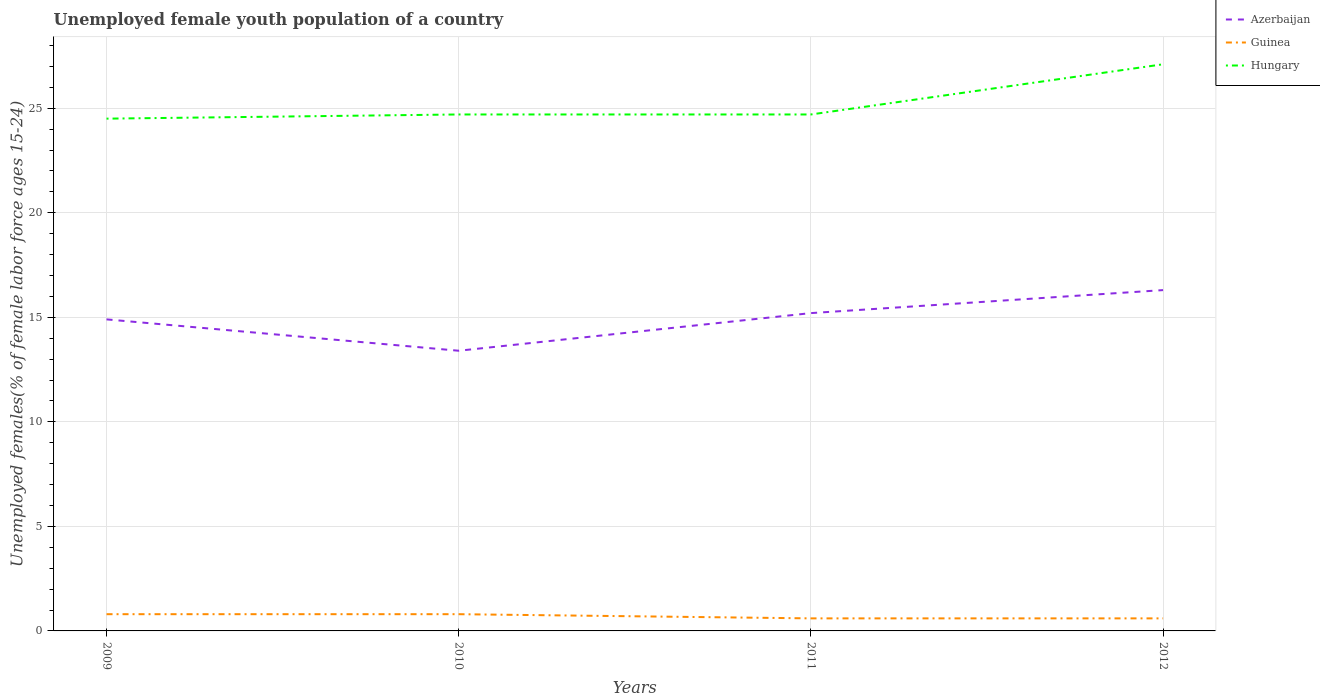Does the line corresponding to Hungary intersect with the line corresponding to Guinea?
Offer a very short reply. No. Is the number of lines equal to the number of legend labels?
Your response must be concise. Yes. Across all years, what is the maximum percentage of unemployed female youth population in Hungary?
Make the answer very short. 24.5. What is the difference between the highest and the second highest percentage of unemployed female youth population in Azerbaijan?
Make the answer very short. 2.9. How many lines are there?
Make the answer very short. 3. How many years are there in the graph?
Your answer should be compact. 4. Are the values on the major ticks of Y-axis written in scientific E-notation?
Your answer should be compact. No. Does the graph contain any zero values?
Ensure brevity in your answer.  No. Where does the legend appear in the graph?
Your answer should be very brief. Top right. How many legend labels are there?
Your answer should be compact. 3. What is the title of the graph?
Your answer should be compact. Unemployed female youth population of a country. What is the label or title of the X-axis?
Ensure brevity in your answer.  Years. What is the label or title of the Y-axis?
Your answer should be compact. Unemployed females(% of female labor force ages 15-24). What is the Unemployed females(% of female labor force ages 15-24) of Azerbaijan in 2009?
Your answer should be very brief. 14.9. What is the Unemployed females(% of female labor force ages 15-24) in Guinea in 2009?
Make the answer very short. 0.8. What is the Unemployed females(% of female labor force ages 15-24) in Hungary in 2009?
Keep it short and to the point. 24.5. What is the Unemployed females(% of female labor force ages 15-24) of Azerbaijan in 2010?
Your response must be concise. 13.4. What is the Unemployed females(% of female labor force ages 15-24) of Guinea in 2010?
Your answer should be compact. 0.8. What is the Unemployed females(% of female labor force ages 15-24) of Hungary in 2010?
Provide a succinct answer. 24.7. What is the Unemployed females(% of female labor force ages 15-24) in Azerbaijan in 2011?
Keep it short and to the point. 15.2. What is the Unemployed females(% of female labor force ages 15-24) of Guinea in 2011?
Ensure brevity in your answer.  0.6. What is the Unemployed females(% of female labor force ages 15-24) in Hungary in 2011?
Offer a very short reply. 24.7. What is the Unemployed females(% of female labor force ages 15-24) of Azerbaijan in 2012?
Give a very brief answer. 16.3. What is the Unemployed females(% of female labor force ages 15-24) of Guinea in 2012?
Offer a very short reply. 0.6. What is the Unemployed females(% of female labor force ages 15-24) in Hungary in 2012?
Make the answer very short. 27.1. Across all years, what is the maximum Unemployed females(% of female labor force ages 15-24) of Azerbaijan?
Offer a terse response. 16.3. Across all years, what is the maximum Unemployed females(% of female labor force ages 15-24) in Guinea?
Make the answer very short. 0.8. Across all years, what is the maximum Unemployed females(% of female labor force ages 15-24) of Hungary?
Provide a short and direct response. 27.1. Across all years, what is the minimum Unemployed females(% of female labor force ages 15-24) in Azerbaijan?
Give a very brief answer. 13.4. Across all years, what is the minimum Unemployed females(% of female labor force ages 15-24) of Guinea?
Make the answer very short. 0.6. Across all years, what is the minimum Unemployed females(% of female labor force ages 15-24) in Hungary?
Provide a succinct answer. 24.5. What is the total Unemployed females(% of female labor force ages 15-24) of Azerbaijan in the graph?
Provide a short and direct response. 59.8. What is the total Unemployed females(% of female labor force ages 15-24) of Hungary in the graph?
Offer a very short reply. 101. What is the difference between the Unemployed females(% of female labor force ages 15-24) in Azerbaijan in 2009 and that in 2010?
Provide a succinct answer. 1.5. What is the difference between the Unemployed females(% of female labor force ages 15-24) of Azerbaijan in 2009 and that in 2011?
Your answer should be very brief. -0.3. What is the difference between the Unemployed females(% of female labor force ages 15-24) of Hungary in 2009 and that in 2011?
Offer a very short reply. -0.2. What is the difference between the Unemployed females(% of female labor force ages 15-24) in Azerbaijan in 2010 and that in 2011?
Give a very brief answer. -1.8. What is the difference between the Unemployed females(% of female labor force ages 15-24) in Guinea in 2010 and that in 2011?
Keep it short and to the point. 0.2. What is the difference between the Unemployed females(% of female labor force ages 15-24) of Hungary in 2010 and that in 2011?
Offer a terse response. 0. What is the difference between the Unemployed females(% of female labor force ages 15-24) in Azerbaijan in 2010 and that in 2012?
Make the answer very short. -2.9. What is the difference between the Unemployed females(% of female labor force ages 15-24) of Guinea in 2010 and that in 2012?
Offer a very short reply. 0.2. What is the difference between the Unemployed females(% of female labor force ages 15-24) in Azerbaijan in 2011 and that in 2012?
Your answer should be compact. -1.1. What is the difference between the Unemployed females(% of female labor force ages 15-24) of Guinea in 2011 and that in 2012?
Ensure brevity in your answer.  0. What is the difference between the Unemployed females(% of female labor force ages 15-24) of Azerbaijan in 2009 and the Unemployed females(% of female labor force ages 15-24) of Guinea in 2010?
Provide a succinct answer. 14.1. What is the difference between the Unemployed females(% of female labor force ages 15-24) in Azerbaijan in 2009 and the Unemployed females(% of female labor force ages 15-24) in Hungary in 2010?
Provide a short and direct response. -9.8. What is the difference between the Unemployed females(% of female labor force ages 15-24) in Guinea in 2009 and the Unemployed females(% of female labor force ages 15-24) in Hungary in 2010?
Make the answer very short. -23.9. What is the difference between the Unemployed females(% of female labor force ages 15-24) of Azerbaijan in 2009 and the Unemployed females(% of female labor force ages 15-24) of Hungary in 2011?
Your answer should be compact. -9.8. What is the difference between the Unemployed females(% of female labor force ages 15-24) of Guinea in 2009 and the Unemployed females(% of female labor force ages 15-24) of Hungary in 2011?
Offer a terse response. -23.9. What is the difference between the Unemployed females(% of female labor force ages 15-24) of Azerbaijan in 2009 and the Unemployed females(% of female labor force ages 15-24) of Guinea in 2012?
Your answer should be compact. 14.3. What is the difference between the Unemployed females(% of female labor force ages 15-24) of Azerbaijan in 2009 and the Unemployed females(% of female labor force ages 15-24) of Hungary in 2012?
Your answer should be compact. -12.2. What is the difference between the Unemployed females(% of female labor force ages 15-24) in Guinea in 2009 and the Unemployed females(% of female labor force ages 15-24) in Hungary in 2012?
Keep it short and to the point. -26.3. What is the difference between the Unemployed females(% of female labor force ages 15-24) of Azerbaijan in 2010 and the Unemployed females(% of female labor force ages 15-24) of Guinea in 2011?
Your response must be concise. 12.8. What is the difference between the Unemployed females(% of female labor force ages 15-24) in Azerbaijan in 2010 and the Unemployed females(% of female labor force ages 15-24) in Hungary in 2011?
Provide a short and direct response. -11.3. What is the difference between the Unemployed females(% of female labor force ages 15-24) in Guinea in 2010 and the Unemployed females(% of female labor force ages 15-24) in Hungary in 2011?
Your answer should be compact. -23.9. What is the difference between the Unemployed females(% of female labor force ages 15-24) of Azerbaijan in 2010 and the Unemployed females(% of female labor force ages 15-24) of Guinea in 2012?
Your answer should be compact. 12.8. What is the difference between the Unemployed females(% of female labor force ages 15-24) of Azerbaijan in 2010 and the Unemployed females(% of female labor force ages 15-24) of Hungary in 2012?
Offer a very short reply. -13.7. What is the difference between the Unemployed females(% of female labor force ages 15-24) in Guinea in 2010 and the Unemployed females(% of female labor force ages 15-24) in Hungary in 2012?
Keep it short and to the point. -26.3. What is the difference between the Unemployed females(% of female labor force ages 15-24) of Guinea in 2011 and the Unemployed females(% of female labor force ages 15-24) of Hungary in 2012?
Make the answer very short. -26.5. What is the average Unemployed females(% of female labor force ages 15-24) in Azerbaijan per year?
Provide a short and direct response. 14.95. What is the average Unemployed females(% of female labor force ages 15-24) of Hungary per year?
Ensure brevity in your answer.  25.25. In the year 2009, what is the difference between the Unemployed females(% of female labor force ages 15-24) of Guinea and Unemployed females(% of female labor force ages 15-24) of Hungary?
Provide a succinct answer. -23.7. In the year 2010, what is the difference between the Unemployed females(% of female labor force ages 15-24) in Guinea and Unemployed females(% of female labor force ages 15-24) in Hungary?
Ensure brevity in your answer.  -23.9. In the year 2011, what is the difference between the Unemployed females(% of female labor force ages 15-24) of Azerbaijan and Unemployed females(% of female labor force ages 15-24) of Guinea?
Your response must be concise. 14.6. In the year 2011, what is the difference between the Unemployed females(% of female labor force ages 15-24) of Azerbaijan and Unemployed females(% of female labor force ages 15-24) of Hungary?
Your answer should be compact. -9.5. In the year 2011, what is the difference between the Unemployed females(% of female labor force ages 15-24) of Guinea and Unemployed females(% of female labor force ages 15-24) of Hungary?
Ensure brevity in your answer.  -24.1. In the year 2012, what is the difference between the Unemployed females(% of female labor force ages 15-24) in Azerbaijan and Unemployed females(% of female labor force ages 15-24) in Guinea?
Provide a succinct answer. 15.7. In the year 2012, what is the difference between the Unemployed females(% of female labor force ages 15-24) of Guinea and Unemployed females(% of female labor force ages 15-24) of Hungary?
Offer a terse response. -26.5. What is the ratio of the Unemployed females(% of female labor force ages 15-24) of Azerbaijan in 2009 to that in 2010?
Ensure brevity in your answer.  1.11. What is the ratio of the Unemployed females(% of female labor force ages 15-24) of Guinea in 2009 to that in 2010?
Offer a very short reply. 1. What is the ratio of the Unemployed females(% of female labor force ages 15-24) in Hungary in 2009 to that in 2010?
Provide a succinct answer. 0.99. What is the ratio of the Unemployed females(% of female labor force ages 15-24) in Azerbaijan in 2009 to that in 2011?
Your answer should be very brief. 0.98. What is the ratio of the Unemployed females(% of female labor force ages 15-24) in Azerbaijan in 2009 to that in 2012?
Your response must be concise. 0.91. What is the ratio of the Unemployed females(% of female labor force ages 15-24) in Hungary in 2009 to that in 2012?
Give a very brief answer. 0.9. What is the ratio of the Unemployed females(% of female labor force ages 15-24) of Azerbaijan in 2010 to that in 2011?
Provide a succinct answer. 0.88. What is the ratio of the Unemployed females(% of female labor force ages 15-24) in Hungary in 2010 to that in 2011?
Offer a terse response. 1. What is the ratio of the Unemployed females(% of female labor force ages 15-24) of Azerbaijan in 2010 to that in 2012?
Your answer should be compact. 0.82. What is the ratio of the Unemployed females(% of female labor force ages 15-24) of Hungary in 2010 to that in 2012?
Make the answer very short. 0.91. What is the ratio of the Unemployed females(% of female labor force ages 15-24) of Azerbaijan in 2011 to that in 2012?
Give a very brief answer. 0.93. What is the ratio of the Unemployed females(% of female labor force ages 15-24) in Hungary in 2011 to that in 2012?
Keep it short and to the point. 0.91. What is the difference between the highest and the second highest Unemployed females(% of female labor force ages 15-24) in Azerbaijan?
Provide a succinct answer. 1.1. What is the difference between the highest and the second highest Unemployed females(% of female labor force ages 15-24) in Guinea?
Provide a short and direct response. 0. What is the difference between the highest and the second highest Unemployed females(% of female labor force ages 15-24) in Hungary?
Provide a succinct answer. 2.4. What is the difference between the highest and the lowest Unemployed females(% of female labor force ages 15-24) in Guinea?
Keep it short and to the point. 0.2. 